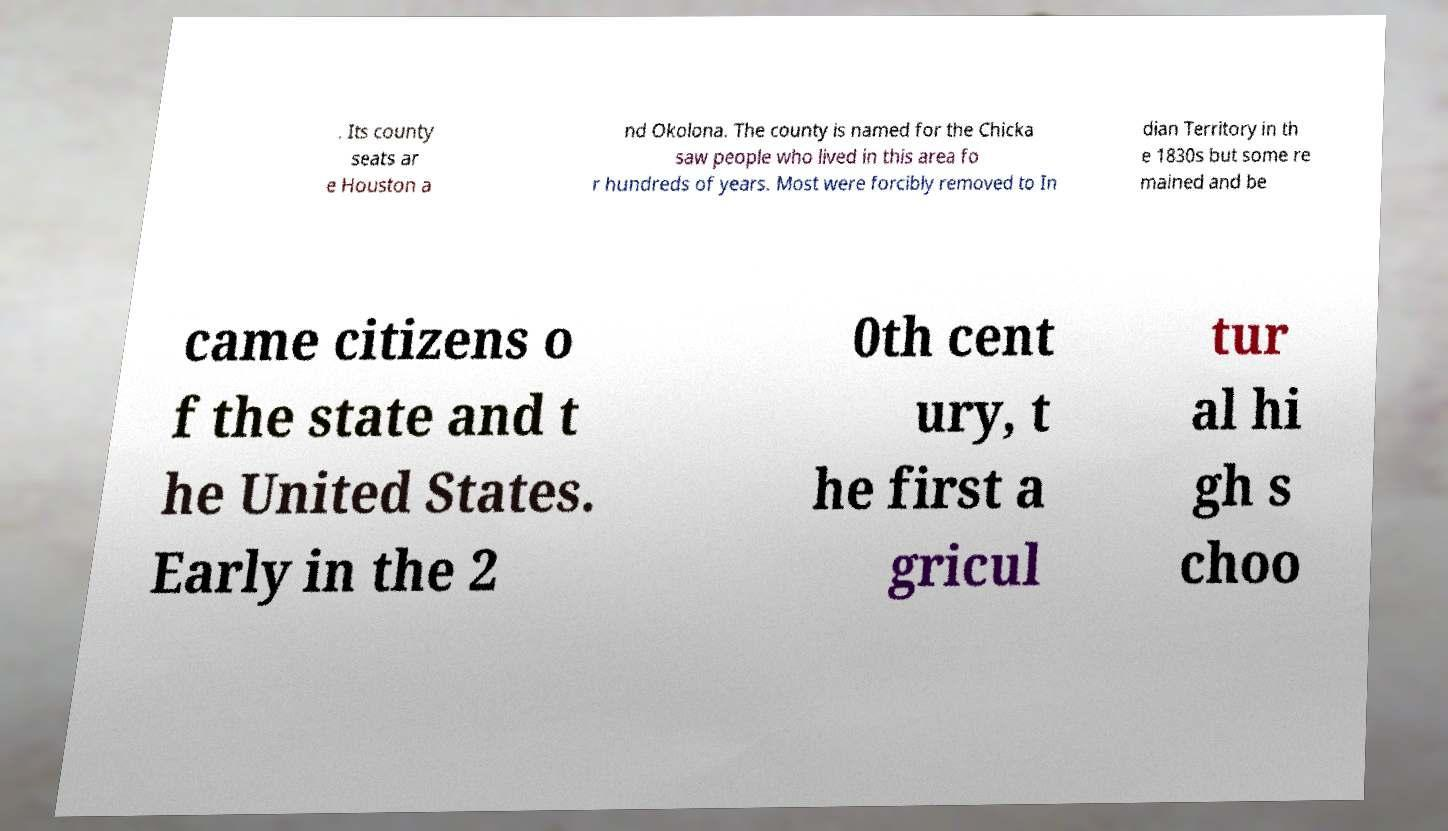Can you accurately transcribe the text from the provided image for me? . Its county seats ar e Houston a nd Okolona. The county is named for the Chicka saw people who lived in this area fo r hundreds of years. Most were forcibly removed to In dian Territory in th e 1830s but some re mained and be came citizens o f the state and t he United States. Early in the 2 0th cent ury, t he first a gricul tur al hi gh s choo 